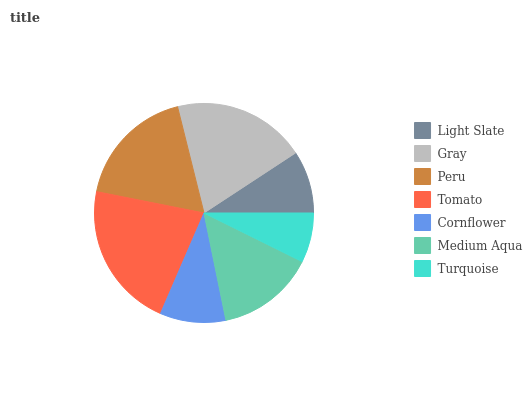Is Turquoise the minimum?
Answer yes or no. Yes. Is Tomato the maximum?
Answer yes or no. Yes. Is Gray the minimum?
Answer yes or no. No. Is Gray the maximum?
Answer yes or no. No. Is Gray greater than Light Slate?
Answer yes or no. Yes. Is Light Slate less than Gray?
Answer yes or no. Yes. Is Light Slate greater than Gray?
Answer yes or no. No. Is Gray less than Light Slate?
Answer yes or no. No. Is Medium Aqua the high median?
Answer yes or no. Yes. Is Medium Aqua the low median?
Answer yes or no. Yes. Is Peru the high median?
Answer yes or no. No. Is Light Slate the low median?
Answer yes or no. No. 